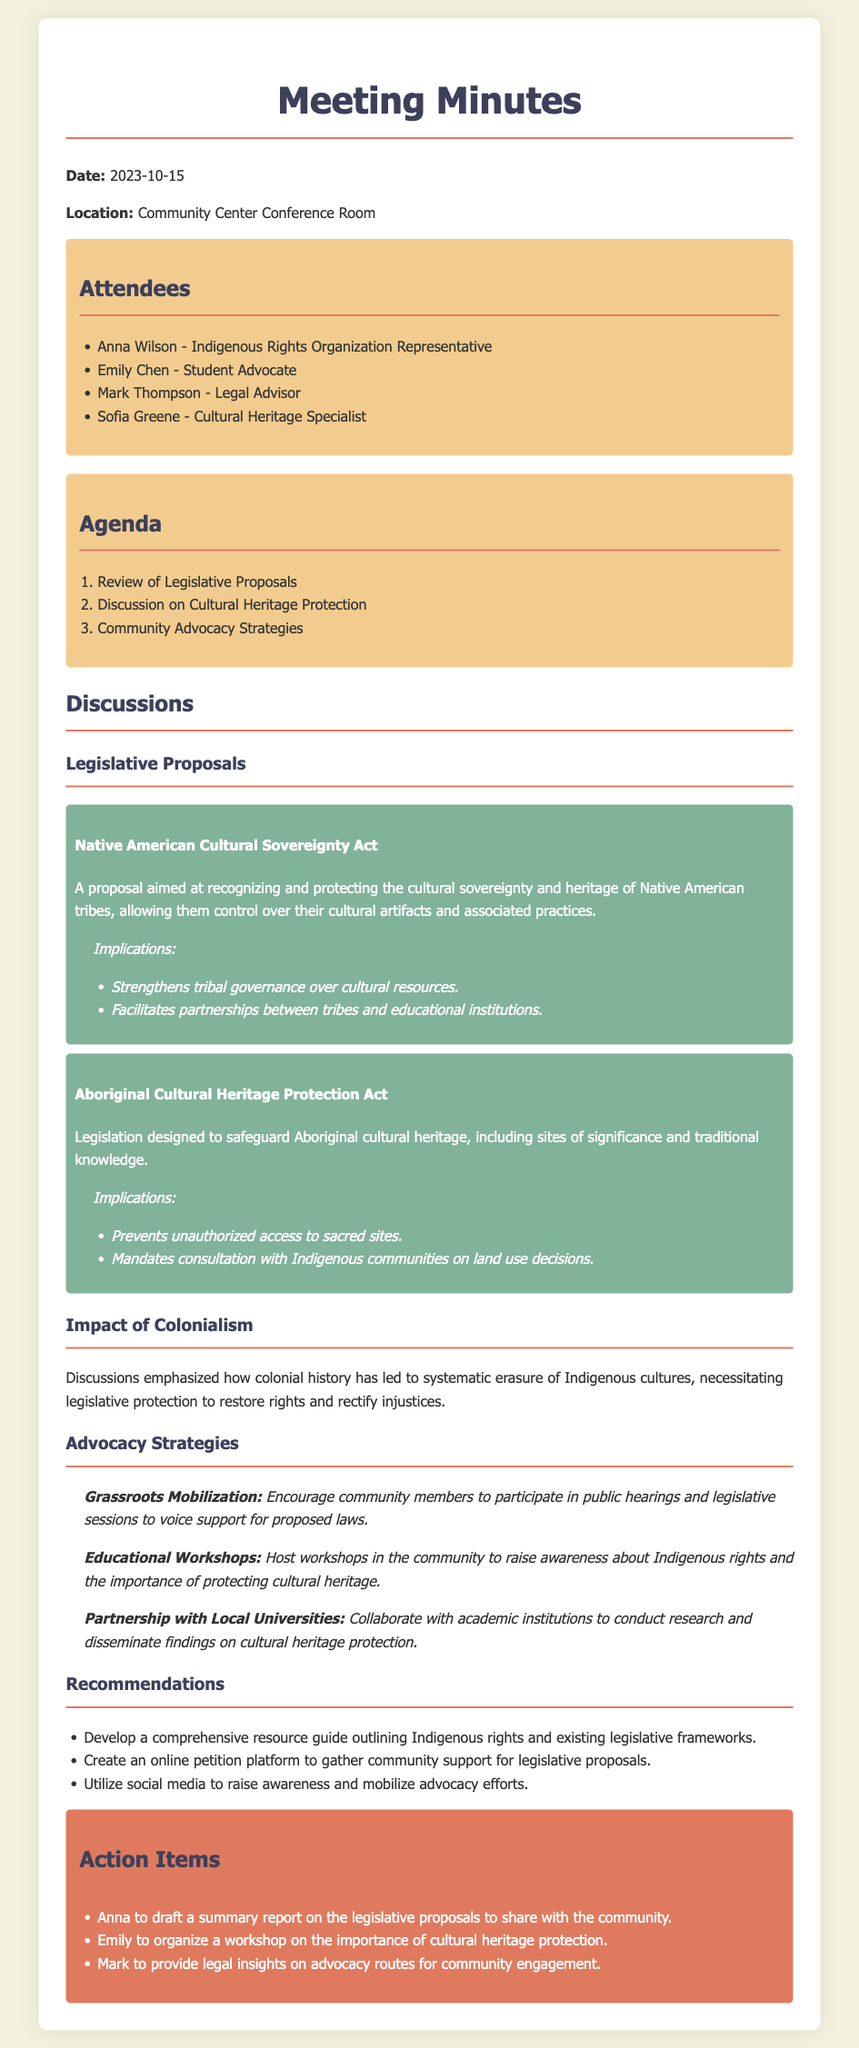What is the date of the meeting? The date of the meeting is mentioned prominently at the beginning of the document.
Answer: 2023-10-15 Who is the Legal Advisor present in the meeting? The document lists attendees, including their roles, to identify who participated.
Answer: Mark Thompson What are the names of the legislative proposals discussed? The titles of the legislative proposals are clearly stated in the discussion section of the document.
Answer: Native American Cultural Sovereignty Act, Aboriginal Cultural Heritage Protection Act What is one recommendation made during the meeting? The document includes a section for recommendations, outlining suggested actions.
Answer: Develop a comprehensive resource guide outlining Indigenous rights and existing legislative frameworks What advocacy strategy involves hosting community events? The document lists various advocacy strategies, including details about community engagement methods.
Answer: Educational Workshops What implication is associated with the Aboriginal Cultural Heritage Protection Act? The document provides specific implications related to each discussed legislative proposal.
Answer: Prevents unauthorized access to sacred sites How many attendees are listed in the document? The document provides a list of attendees, which can be counted for this information.
Answer: 4 What is Anna tasked to do after the meeting? The action items section outlines specific tasks assigned to attendees following the discussions.
Answer: Draft a summary report on the legislative proposals to share with the community 